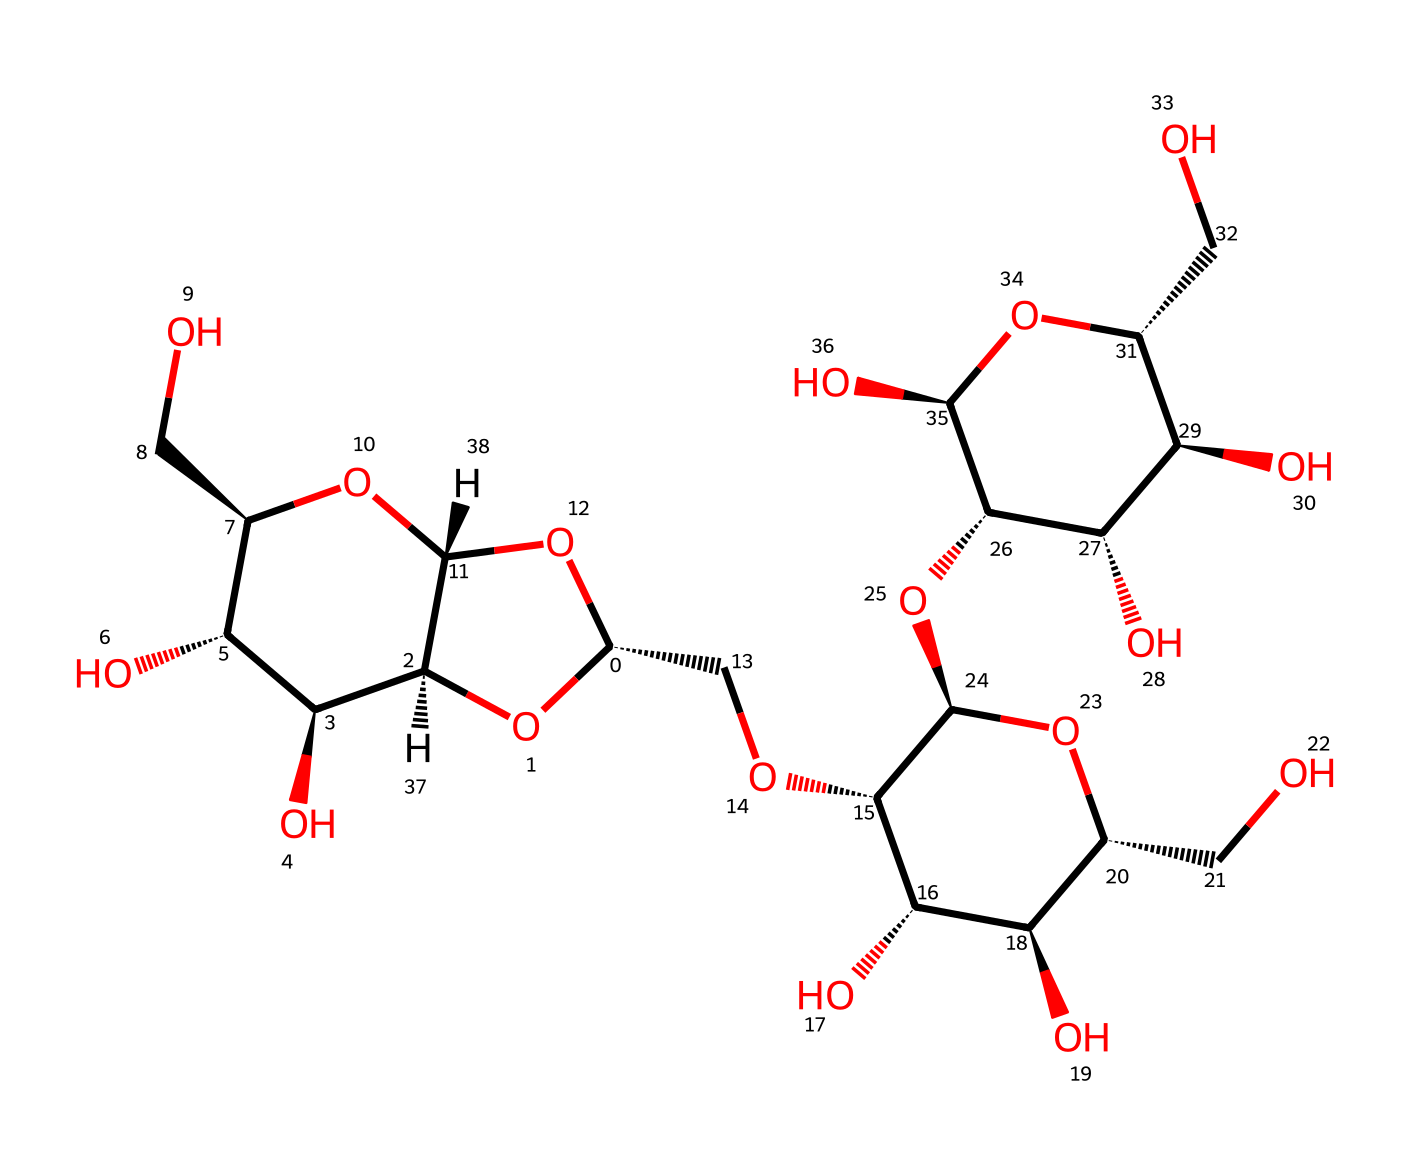What is the primary function of cellulose in the human diet? Cellulose acts as dietary fiber, promoting digestive health by facilitating regular bowel movements and preventing constipation.
Answer: dietary fiber How many carbon atoms are present in the cellulose structure? Cellulose consists of a repeating unit that contains six carbon atoms per monomer. Counting the total carbons in the structure reveals a total of about 6 carbon units in the backbone, leading to approximately 72 carbon atoms across the entire molecule.
Answer: 72 What type of linkage connects the glucose units in cellulose? The glucose units in cellulose are connected through β(1→4) glycosidic linkages, which are unique to cellulose and contribute to its structural properties.
Answer: β(1→4) glycosidic linkage What is the main functional group present in cellulose? The predominant functional group in cellulose is hydroxyl groups (-OH), which are abundant and contribute to its solubility and hydrogen bonding capabilities.
Answer: hydroxyl How does the structure of cellulose differ from that of starch? While both cellulose and starch are polysaccharides composed of glucose units, cellulose has β(1→4) linkages giving it a straight chain structure, whereas starch consists of α(1→4) linkages, allowing for branching.
Answer: straight chain structure 